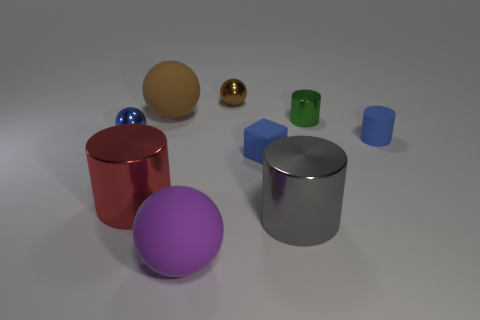Can you tell me what materials the objects seem to be made of based on their appearance? The red and gray cylinders appear to have a metallic sheen, suggesting they are made of metal. The purple object looks like a matte plastic sphere, while the blue cube and cylinders have a more reflective plastic look. The brown sphere has a slight matte finish as well, which could imply a rubbery texture. 